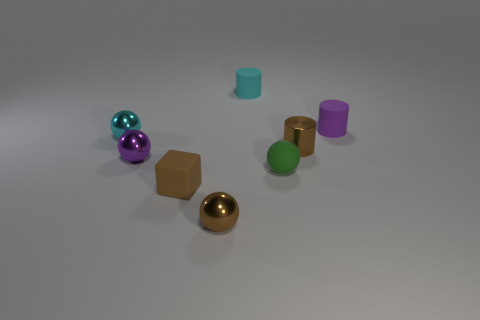There is a cyan object on the left side of the cyan matte object; how big is it?
Offer a terse response. Small. How many other objects are the same color as the small metallic cylinder?
Your response must be concise. 2. What is the material of the cyan object that is on the left side of the brown shiny thing in front of the tiny brown block?
Ensure brevity in your answer.  Metal. There is a tiny matte cylinder behind the tiny purple matte object; does it have the same color as the small rubber ball?
Offer a very short reply. No. Are there any other things that have the same material as the tiny cyan ball?
Give a very brief answer. Yes. What number of other things are the same shape as the tiny cyan rubber object?
Your answer should be compact. 2. What size is the cyan cylinder that is made of the same material as the tiny green object?
Ensure brevity in your answer.  Small. There is a purple object that is to the right of the tiny brown object behind the small rubber block; is there a cyan metal thing that is on the right side of it?
Offer a very short reply. No. There is a green rubber thing that is to the right of the brown ball; is its size the same as the tiny matte cube?
Offer a very short reply. Yes. What number of other brown cubes have the same size as the block?
Offer a terse response. 0. 